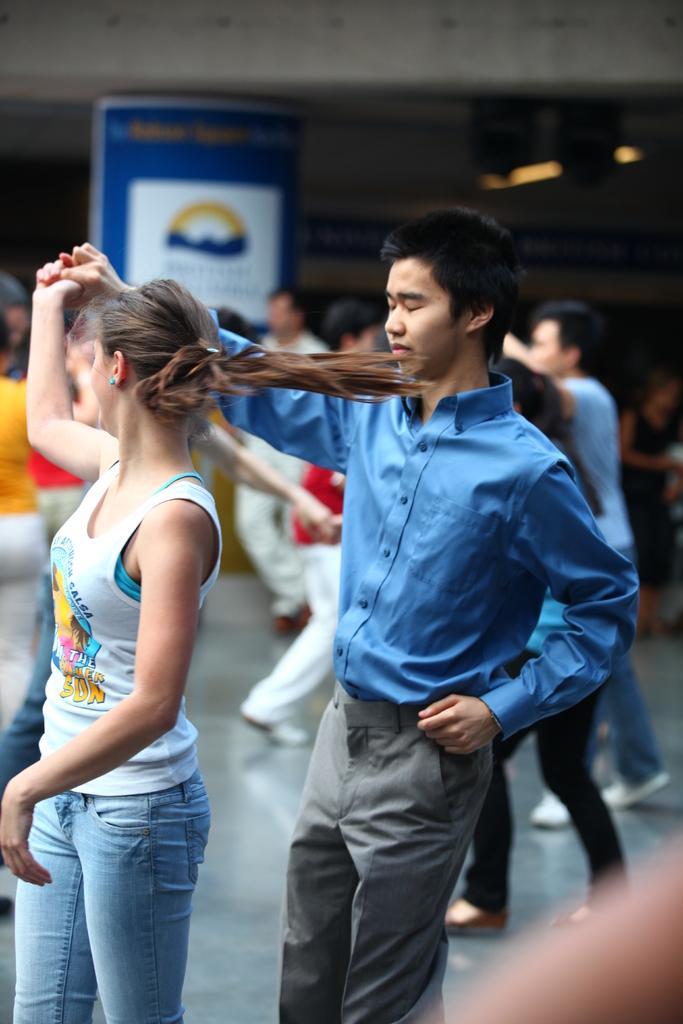Describe this image in one or two sentences. In this image we can see the people dancing on the floor. In the background we can see the banner, ceiling and also the lights. 